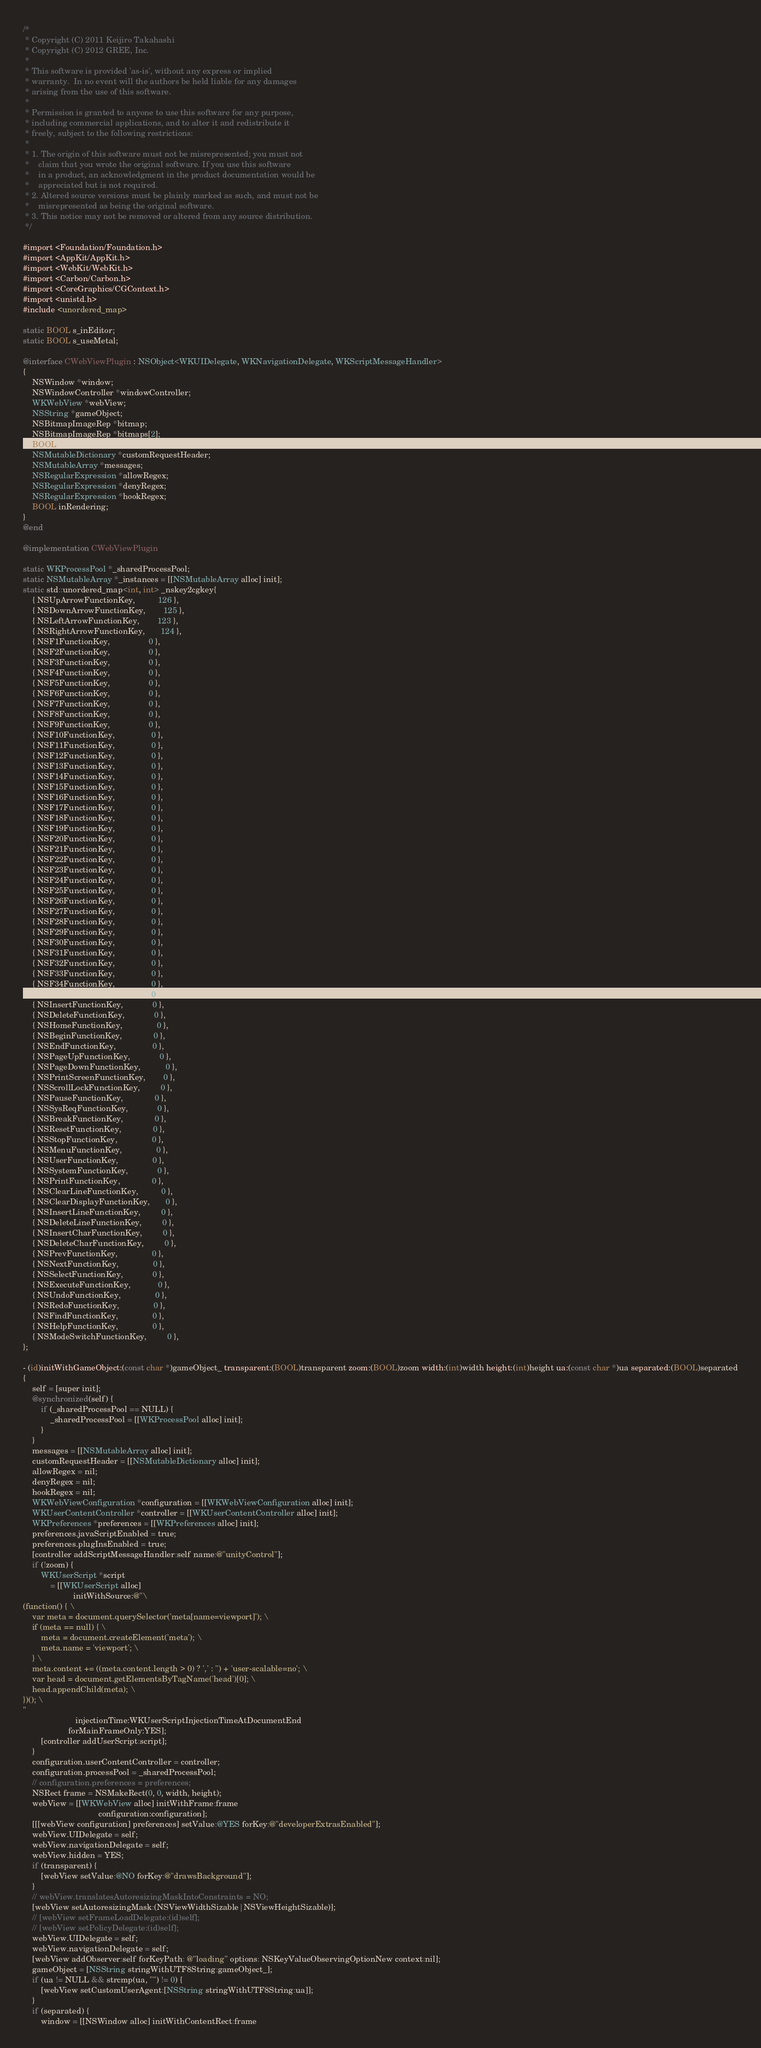<code> <loc_0><loc_0><loc_500><loc_500><_ObjectiveC_>/*
 * Copyright (C) 2011 Keijiro Takahashi
 * Copyright (C) 2012 GREE, Inc.
 *
 * This software is provided 'as-is', without any express or implied
 * warranty.  In no event will the authors be held liable for any damages
 * arising from the use of this software.
 *
 * Permission is granted to anyone to use this software for any purpose,
 * including commercial applications, and to alter it and redistribute it
 * freely, subject to the following restrictions:
 *
 * 1. The origin of this software must not be misrepresented; you must not
 *    claim that you wrote the original software. If you use this software
 *    in a product, an acknowledgment in the product documentation would be
 *    appreciated but is not required.
 * 2. Altered source versions must be plainly marked as such, and must not be
 *    misrepresented as being the original software.
 * 3. This notice may not be removed or altered from any source distribution.
 */

#import <Foundation/Foundation.h>
#import <AppKit/AppKit.h>
#import <WebKit/WebKit.h>
#import <Carbon/Carbon.h>
#import <CoreGraphics/CGContext.h>
#import <unistd.h>
#include <unordered_map>

static BOOL s_inEditor;
static BOOL s_useMetal;

@interface CWebViewPlugin : NSObject<WKUIDelegate, WKNavigationDelegate, WKScriptMessageHandler>
{
    NSWindow *window;
    NSWindowController *windowController;
    WKWebView *webView;
    NSString *gameObject;
    NSBitmapImageRep *bitmap;
    NSBitmapImageRep *bitmaps[2];
    BOOL needsDisplay;
    NSMutableDictionary *customRequestHeader;
    NSMutableArray *messages;
    NSRegularExpression *allowRegex;
    NSRegularExpression *denyRegex;
    NSRegularExpression *hookRegex;
    BOOL inRendering;
}
@end

@implementation CWebViewPlugin

static WKProcessPool *_sharedProcessPool;
static NSMutableArray *_instances = [[NSMutableArray alloc] init];
static std::unordered_map<int, int> _nskey2cgkey{
    { NSUpArrowFunctionKey,          126 },
    { NSDownArrowFunctionKey,        125 },
    { NSLeftArrowFunctionKey,        123 },
    { NSRightArrowFunctionKey,       124 },
    { NSF1FunctionKey,                 0 },
    { NSF2FunctionKey,                 0 },
    { NSF3FunctionKey,                 0 },
    { NSF4FunctionKey,                 0 },
    { NSF5FunctionKey,                 0 },
    { NSF6FunctionKey,                 0 },
    { NSF7FunctionKey,                 0 },
    { NSF8FunctionKey,                 0 },
    { NSF9FunctionKey,                 0 },
    { NSF10FunctionKey,                0 },
    { NSF11FunctionKey,                0 },
    { NSF12FunctionKey,                0 },
    { NSF13FunctionKey,                0 },
    { NSF14FunctionKey,                0 },
    { NSF15FunctionKey,                0 },
    { NSF16FunctionKey,                0 },
    { NSF17FunctionKey,                0 },
    { NSF18FunctionKey,                0 },
    { NSF19FunctionKey,                0 },
    { NSF20FunctionKey,                0 },
    { NSF21FunctionKey,                0 },
    { NSF22FunctionKey,                0 },
    { NSF23FunctionKey,                0 },
    { NSF24FunctionKey,                0 },
    { NSF25FunctionKey,                0 },
    { NSF26FunctionKey,                0 },
    { NSF27FunctionKey,                0 },
    { NSF28FunctionKey,                0 },
    { NSF29FunctionKey,                0 },
    { NSF30FunctionKey,                0 },
    { NSF31FunctionKey,                0 },
    { NSF32FunctionKey,                0 },
    { NSF33FunctionKey,                0 },
    { NSF34FunctionKey,                0 },
    { NSF35FunctionKey,                0 },
    { NSInsertFunctionKey,             0 },
    { NSDeleteFunctionKey,             0 },
    { NSHomeFunctionKey,               0 },
    { NSBeginFunctionKey,              0 },
    { NSEndFunctionKey,                0 },
    { NSPageUpFunctionKey,             0 },
    { NSPageDownFunctionKey,           0 },
    { NSPrintScreenFunctionKey,        0 },
    { NSScrollLockFunctionKey,         0 },
    { NSPauseFunctionKey,              0 },
    { NSSysReqFunctionKey,             0 },
    { NSBreakFunctionKey,              0 },
    { NSResetFunctionKey,              0 },
    { NSStopFunctionKey,               0 },
    { NSMenuFunctionKey,               0 },
    { NSUserFunctionKey,               0 },
    { NSSystemFunctionKey,             0 },
    { NSPrintFunctionKey,              0 },
    { NSClearLineFunctionKey,          0 },
    { NSClearDisplayFunctionKey,       0 },
    { NSInsertLineFunctionKey,         0 },
    { NSDeleteLineFunctionKey,         0 },
    { NSInsertCharFunctionKey,         0 },
    { NSDeleteCharFunctionKey,         0 },
    { NSPrevFunctionKey,               0 },
    { NSNextFunctionKey,               0 },
    { NSSelectFunctionKey,             0 },
    { NSExecuteFunctionKey,            0 },
    { NSUndoFunctionKey,               0 },
    { NSRedoFunctionKey,               0 },
    { NSFindFunctionKey,               0 },
    { NSHelpFunctionKey,               0 },
    { NSModeSwitchFunctionKey,         0 },
};

- (id)initWithGameObject:(const char *)gameObject_ transparent:(BOOL)transparent zoom:(BOOL)zoom width:(int)width height:(int)height ua:(const char *)ua separated:(BOOL)separated
{
    self = [super init];
    @synchronized(self) {
        if (_sharedProcessPool == NULL) {
            _sharedProcessPool = [[WKProcessPool alloc] init];
        }
    }
    messages = [[NSMutableArray alloc] init];
    customRequestHeader = [[NSMutableDictionary alloc] init];
    allowRegex = nil;
    denyRegex = nil;
    hookRegex = nil;
    WKWebViewConfiguration *configuration = [[WKWebViewConfiguration alloc] init];
    WKUserContentController *controller = [[WKUserContentController alloc] init];
    WKPreferences *preferences = [[WKPreferences alloc] init];
    preferences.javaScriptEnabled = true;
    preferences.plugInsEnabled = true;
    [controller addScriptMessageHandler:self name:@"unityControl"];
    if (!zoom) {
        WKUserScript *script
            = [[WKUserScript alloc]
                      initWithSource:@"\
(function() { \
    var meta = document.querySelector('meta[name=viewport]'); \
    if (meta == null) { \
        meta = document.createElement('meta'); \
        meta.name = 'viewport'; \
    } \
    meta.content += ((meta.content.length > 0) ? ',' : '') + 'user-scalable=no'; \
    var head = document.getElementsByTagName('head')[0]; \
    head.appendChild(meta); \
})(); \
"
                       injectionTime:WKUserScriptInjectionTimeAtDocumentEnd
                    forMainFrameOnly:YES];
        [controller addUserScript:script];
    }
    configuration.userContentController = controller;
    configuration.processPool = _sharedProcessPool;
    // configuration.preferences = preferences;
    NSRect frame = NSMakeRect(0, 0, width, height);
    webView = [[WKWebView alloc] initWithFrame:frame
                                 configuration:configuration];
    [[[webView configuration] preferences] setValue:@YES forKey:@"developerExtrasEnabled"];
    webView.UIDelegate = self;
    webView.navigationDelegate = self;
    webView.hidden = YES;
    if (transparent) {
        [webView setValue:@NO forKey:@"drawsBackground"];
    }
    // webView.translatesAutoresizingMaskIntoConstraints = NO;
    [webView setAutoresizingMask:(NSViewWidthSizable|NSViewHeightSizable)];
    // [webView setFrameLoadDelegate:(id)self];
    // [webView setPolicyDelegate:(id)self];
    webView.UIDelegate = self;
    webView.navigationDelegate = self;
    [webView addObserver:self forKeyPath: @"loading" options: NSKeyValueObservingOptionNew context:nil];
    gameObject = [NSString stringWithUTF8String:gameObject_];
    if (ua != NULL && strcmp(ua, "") != 0) {
        [webView setCustomUserAgent:[NSString stringWithUTF8String:ua]];
    }
    if (separated) {
        window = [[NSWindow alloc] initWithContentRect:frame</code> 